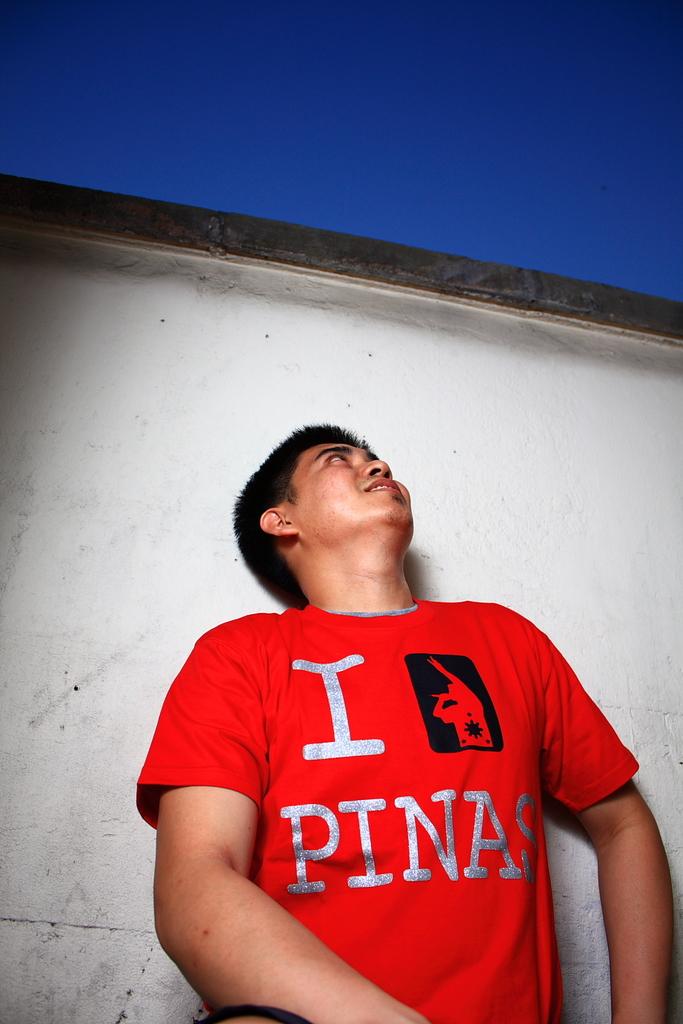What's the last word on the man's shirt?
Give a very brief answer. Pinas. 